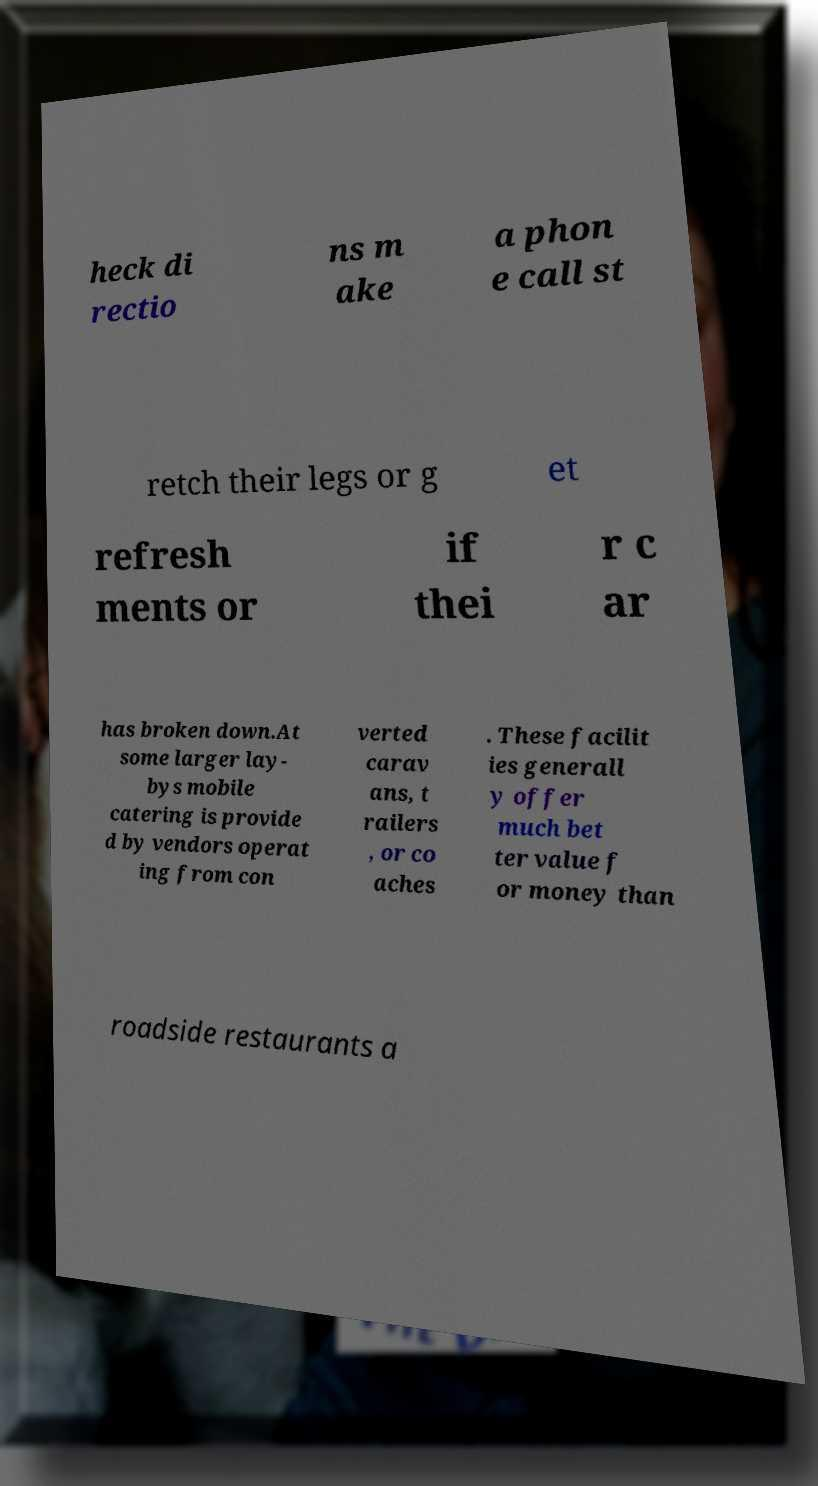Can you accurately transcribe the text from the provided image for me? heck di rectio ns m ake a phon e call st retch their legs or g et refresh ments or if thei r c ar has broken down.At some larger lay- bys mobile catering is provide d by vendors operat ing from con verted carav ans, t railers , or co aches . These facilit ies generall y offer much bet ter value f or money than roadside restaurants a 